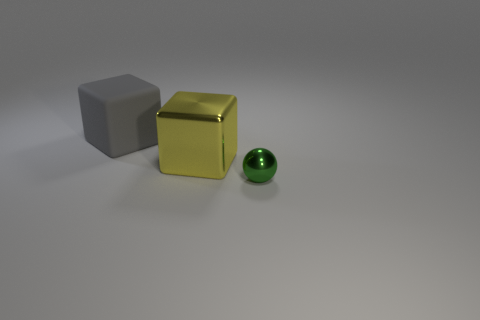How big is the green metallic thing?
Your response must be concise. Small. Are there fewer yellow blocks than large gray balls?
Ensure brevity in your answer.  No. How many tiny spheres are the same color as the large metal cube?
Your answer should be very brief. 0. Do the metal object behind the green metallic ball and the big matte thing have the same color?
Provide a succinct answer. No. What shape is the metallic object right of the yellow object?
Ensure brevity in your answer.  Sphere. Is there a tiny green thing that is in front of the tiny object that is to the right of the rubber cube?
Your answer should be compact. No. How many other small green spheres have the same material as the ball?
Your response must be concise. 0. There is a shiny object that is to the left of the thing on the right side of the shiny thing behind the sphere; what size is it?
Give a very brief answer. Large. There is a metal ball; what number of green shiny things are right of it?
Provide a succinct answer. 0. Are there more tiny shiny things than blue metallic objects?
Your response must be concise. Yes. 